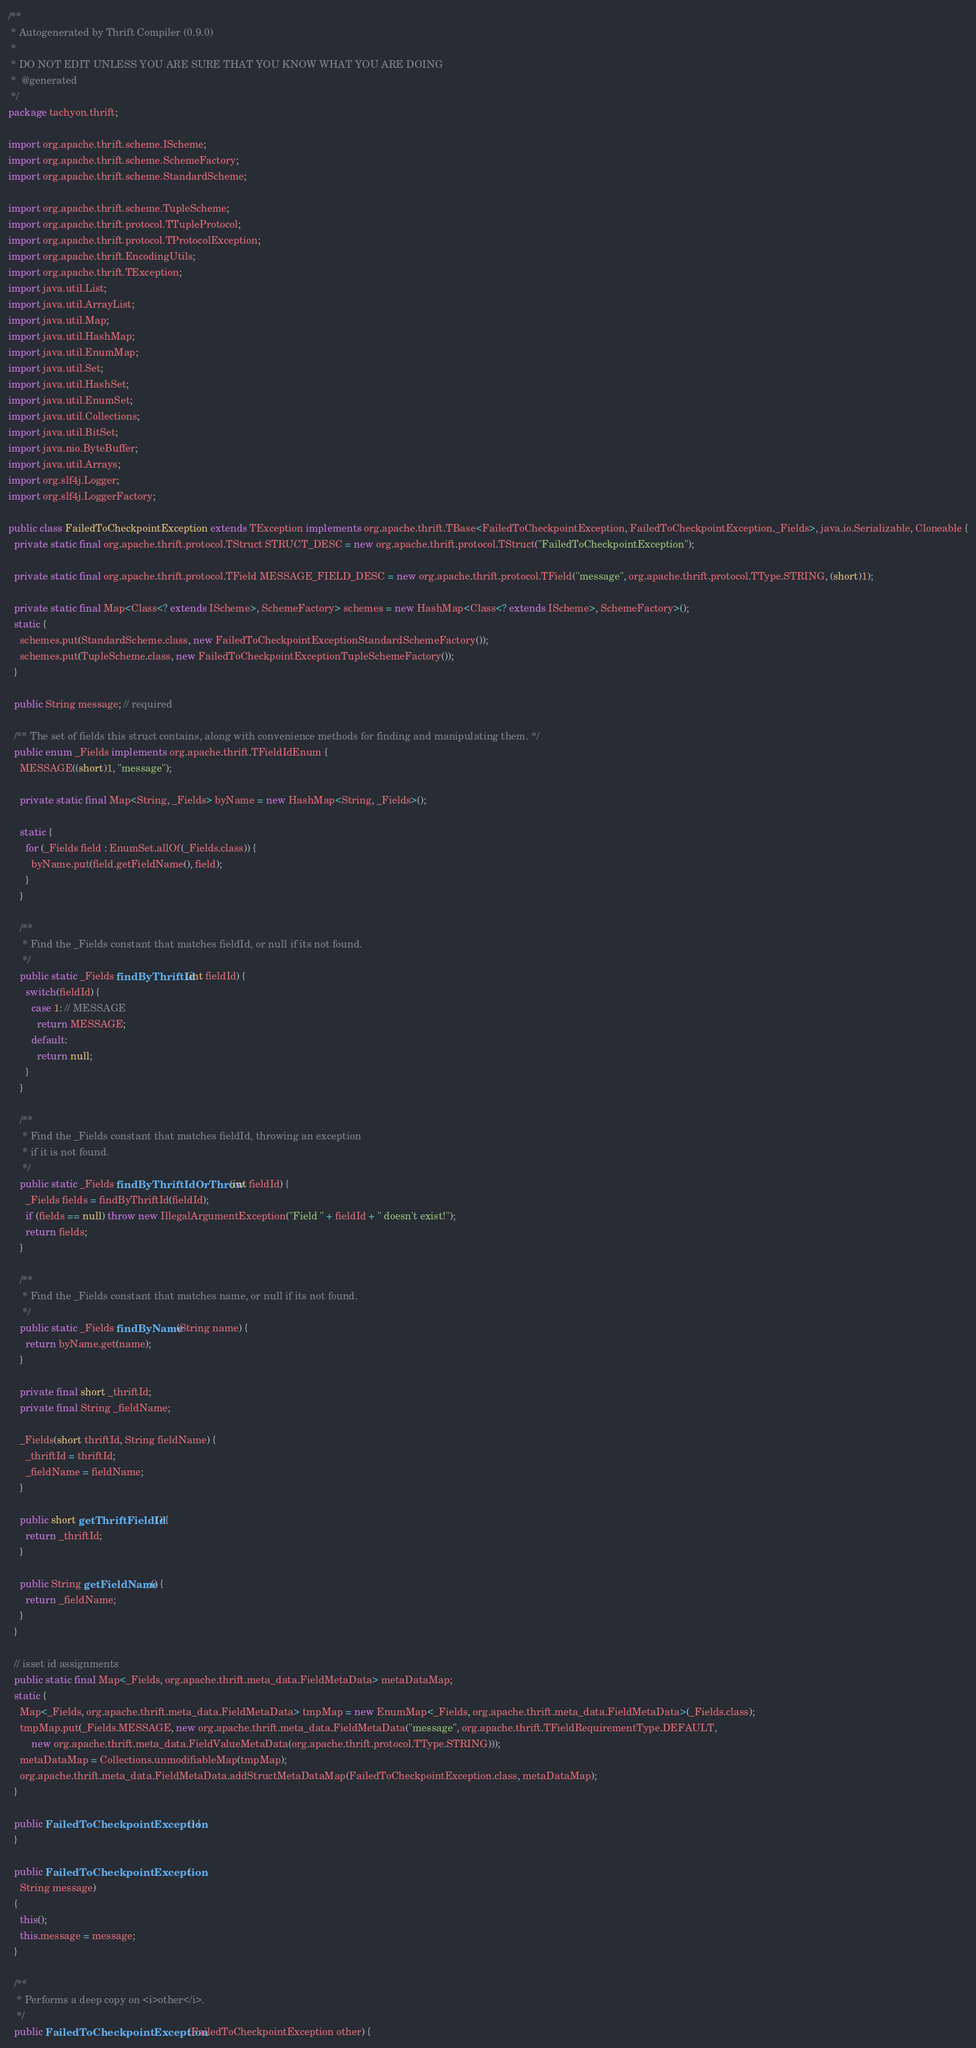<code> <loc_0><loc_0><loc_500><loc_500><_Java_>/**
 * Autogenerated by Thrift Compiler (0.9.0)
 *
 * DO NOT EDIT UNLESS YOU ARE SURE THAT YOU KNOW WHAT YOU ARE DOING
 *  @generated
 */
package tachyon.thrift;

import org.apache.thrift.scheme.IScheme;
import org.apache.thrift.scheme.SchemeFactory;
import org.apache.thrift.scheme.StandardScheme;

import org.apache.thrift.scheme.TupleScheme;
import org.apache.thrift.protocol.TTupleProtocol;
import org.apache.thrift.protocol.TProtocolException;
import org.apache.thrift.EncodingUtils;
import org.apache.thrift.TException;
import java.util.List;
import java.util.ArrayList;
import java.util.Map;
import java.util.HashMap;
import java.util.EnumMap;
import java.util.Set;
import java.util.HashSet;
import java.util.EnumSet;
import java.util.Collections;
import java.util.BitSet;
import java.nio.ByteBuffer;
import java.util.Arrays;
import org.slf4j.Logger;
import org.slf4j.LoggerFactory;

public class FailedToCheckpointException extends TException implements org.apache.thrift.TBase<FailedToCheckpointException, FailedToCheckpointException._Fields>, java.io.Serializable, Cloneable {
  private static final org.apache.thrift.protocol.TStruct STRUCT_DESC = new org.apache.thrift.protocol.TStruct("FailedToCheckpointException");

  private static final org.apache.thrift.protocol.TField MESSAGE_FIELD_DESC = new org.apache.thrift.protocol.TField("message", org.apache.thrift.protocol.TType.STRING, (short)1);

  private static final Map<Class<? extends IScheme>, SchemeFactory> schemes = new HashMap<Class<? extends IScheme>, SchemeFactory>();
  static {
    schemes.put(StandardScheme.class, new FailedToCheckpointExceptionStandardSchemeFactory());
    schemes.put(TupleScheme.class, new FailedToCheckpointExceptionTupleSchemeFactory());
  }

  public String message; // required

  /** The set of fields this struct contains, along with convenience methods for finding and manipulating them. */
  public enum _Fields implements org.apache.thrift.TFieldIdEnum {
    MESSAGE((short)1, "message");

    private static final Map<String, _Fields> byName = new HashMap<String, _Fields>();

    static {
      for (_Fields field : EnumSet.allOf(_Fields.class)) {
        byName.put(field.getFieldName(), field);
      }
    }

    /**
     * Find the _Fields constant that matches fieldId, or null if its not found.
     */
    public static _Fields findByThriftId(int fieldId) {
      switch(fieldId) {
        case 1: // MESSAGE
          return MESSAGE;
        default:
          return null;
      }
    }

    /**
     * Find the _Fields constant that matches fieldId, throwing an exception
     * if it is not found.
     */
    public static _Fields findByThriftIdOrThrow(int fieldId) {
      _Fields fields = findByThriftId(fieldId);
      if (fields == null) throw new IllegalArgumentException("Field " + fieldId + " doesn't exist!");
      return fields;
    }

    /**
     * Find the _Fields constant that matches name, or null if its not found.
     */
    public static _Fields findByName(String name) {
      return byName.get(name);
    }

    private final short _thriftId;
    private final String _fieldName;

    _Fields(short thriftId, String fieldName) {
      _thriftId = thriftId;
      _fieldName = fieldName;
    }

    public short getThriftFieldId() {
      return _thriftId;
    }

    public String getFieldName() {
      return _fieldName;
    }
  }

  // isset id assignments
  public static final Map<_Fields, org.apache.thrift.meta_data.FieldMetaData> metaDataMap;
  static {
    Map<_Fields, org.apache.thrift.meta_data.FieldMetaData> tmpMap = new EnumMap<_Fields, org.apache.thrift.meta_data.FieldMetaData>(_Fields.class);
    tmpMap.put(_Fields.MESSAGE, new org.apache.thrift.meta_data.FieldMetaData("message", org.apache.thrift.TFieldRequirementType.DEFAULT, 
        new org.apache.thrift.meta_data.FieldValueMetaData(org.apache.thrift.protocol.TType.STRING)));
    metaDataMap = Collections.unmodifiableMap(tmpMap);
    org.apache.thrift.meta_data.FieldMetaData.addStructMetaDataMap(FailedToCheckpointException.class, metaDataMap);
  }

  public FailedToCheckpointException() {
  }

  public FailedToCheckpointException(
    String message)
  {
    this();
    this.message = message;
  }

  /**
   * Performs a deep copy on <i>other</i>.
   */
  public FailedToCheckpointException(FailedToCheckpointException other) {</code> 